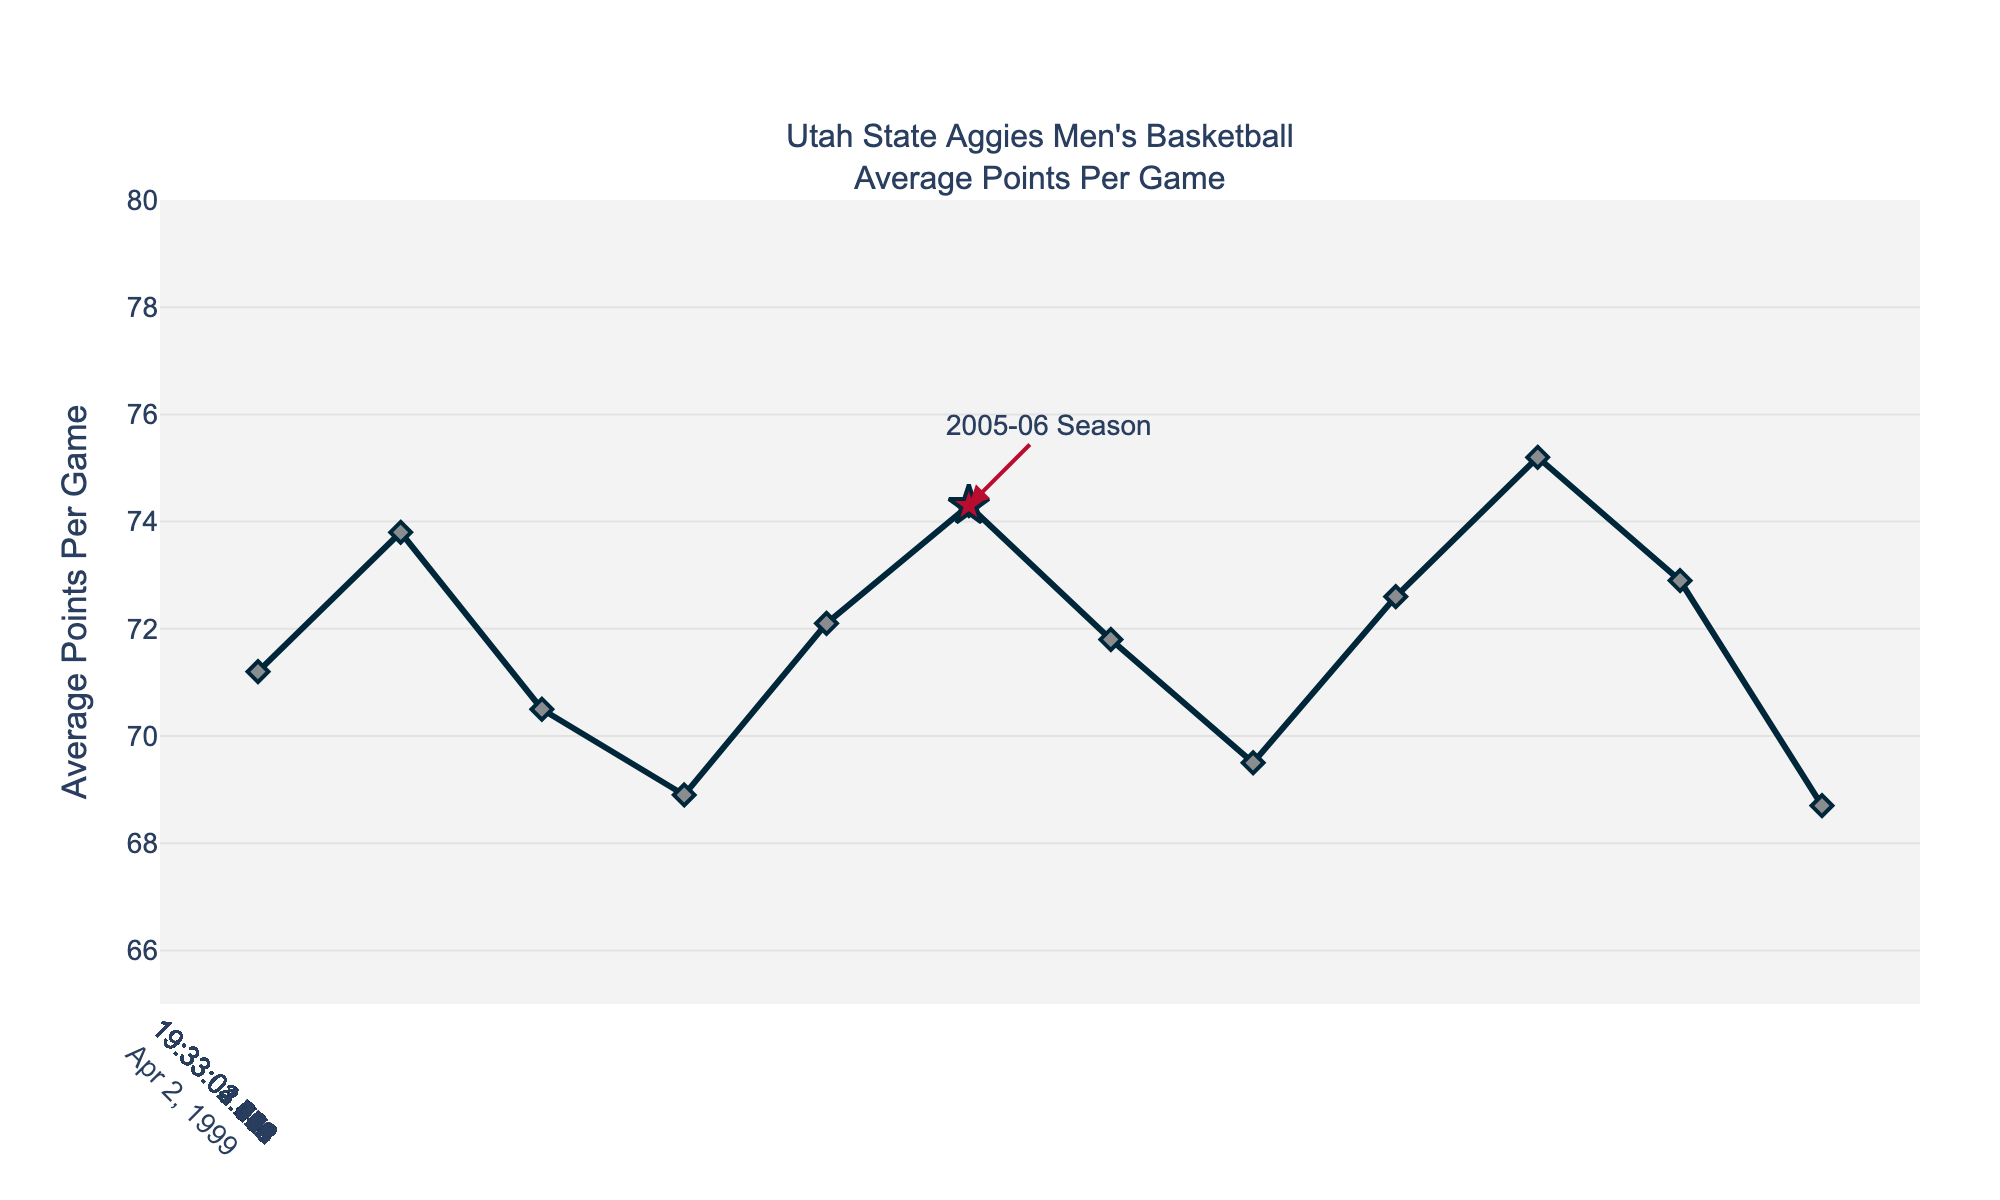What's the highest average points per game in any season? Identify the peak value in the y-axis, which represents the average points per game. Here, it peaks at 76.2 during the 2018-19 season.
Answer: 76.2 Was the average points per game higher in the 2005-06 season compared to the 2010-11 season? Compare the values for the 2005-06 (74.3) and 2010-11 (72.9) seasons. 74.3 > 72.9, hence yes, it was higher.
Answer: Yes Which season had the lowest average points per game? Find the lowest point in the line chart. It corresponds to the 2014-15 season with an average of 67.8 points per game.
Answer: 2014-15 What is the average points per game difference between the 2005-06 and 2019-20 seasons? Subtract the average points per game of the 2005-06 season (74.3) from that of the 2019-20 season (75.8). The difference is 75.8 - 74.3 = 1.5.
Answer: 1.5 Compare the trend in average points per game from 2000-01 to 2009-10 with that from 2010-11 to 2022-23. Which period generally had higher values? Visually estimate the overall trend by examining the peaks and valleys in both periods. From 2000-01 to 2009-10, several highs around mid-70s are seen. From 2010-11 to 2022-23, despite some peaks, overall values frequently oscillate around early 70s.
Answer: 2000-01 to 2009-10 What visual marker is used to highlight the 2005-06 season? Identify the distinct visual attribute used. For the 2005-06 season, a large red star marker is used.
Answer: Large red star How many seasons had an average points per game above 75? Count the number of data points that exceed the 75 mark on the y-axis. These occur in the 2009-10, 2018-19, 2019-20, and 2022-23 seasons.
Answer: 4 Describe the overall trend in average points per game from 2000 to 2023. Observing the line graph, the average points per game have non-linear fluctuations, with notable higher values around 2005-06, 2009-10, and post-2017 seasons.
Answer: Fluctuating In which years did the average points per game increase compared to the previous season across the entire period? Identify years with upward segments from the previous year's point. Increases are visible in 2001-02, 2004-05, 2005-06, 2008-09, 2010-11, 2013-14, 2016-17, 2017-18, 2018-19, 2019-20, 2021-22, and 2022-23.
Answer: 12 times 